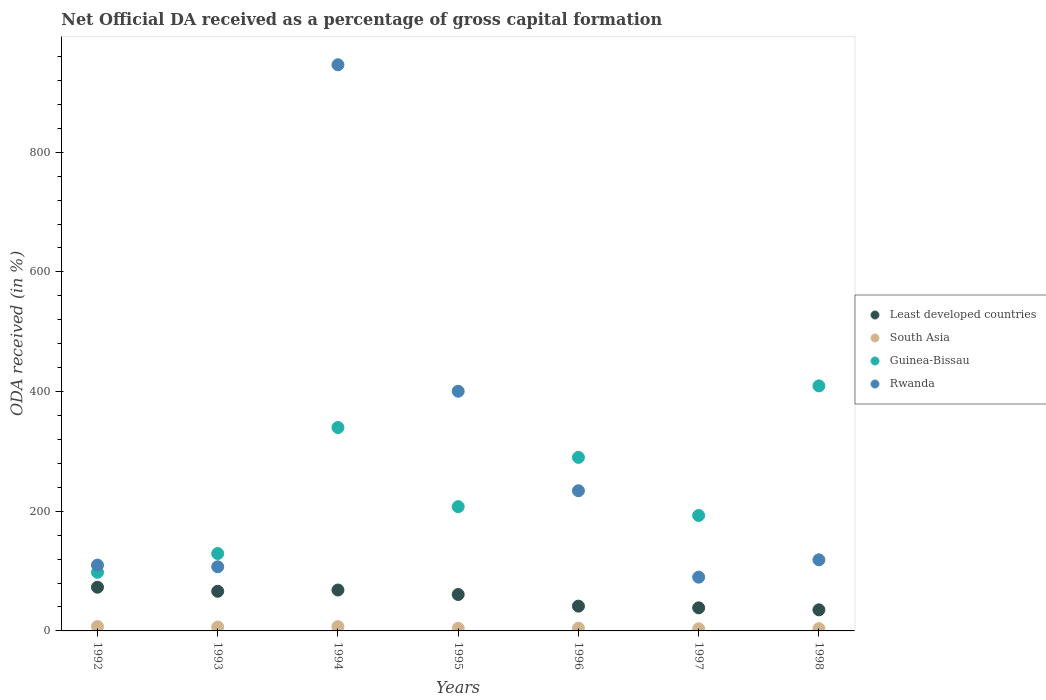Is the number of dotlines equal to the number of legend labels?
Give a very brief answer. Yes. What is the net ODA received in Rwanda in 1994?
Offer a very short reply. 946.08. Across all years, what is the maximum net ODA received in Least developed countries?
Make the answer very short. 73.05. Across all years, what is the minimum net ODA received in Least developed countries?
Provide a succinct answer. 35.24. What is the total net ODA received in Least developed countries in the graph?
Your answer should be very brief. 383.72. What is the difference between the net ODA received in Least developed countries in 1994 and that in 1996?
Provide a short and direct response. 26.97. What is the difference between the net ODA received in Guinea-Bissau in 1993 and the net ODA received in South Asia in 1996?
Offer a terse response. 124.72. What is the average net ODA received in Rwanda per year?
Keep it short and to the point. 286.67. In the year 1992, what is the difference between the net ODA received in Guinea-Bissau and net ODA received in Least developed countries?
Provide a succinct answer. 24.92. What is the ratio of the net ODA received in Guinea-Bissau in 1993 to that in 1998?
Your answer should be very brief. 0.32. What is the difference between the highest and the second highest net ODA received in Rwanda?
Provide a succinct answer. 545.56. What is the difference between the highest and the lowest net ODA received in South Asia?
Give a very brief answer. 3.85. In how many years, is the net ODA received in Guinea-Bissau greater than the average net ODA received in Guinea-Bissau taken over all years?
Your answer should be very brief. 3. Is it the case that in every year, the sum of the net ODA received in Rwanda and net ODA received in Least developed countries  is greater than the sum of net ODA received in South Asia and net ODA received in Guinea-Bissau?
Ensure brevity in your answer.  Yes. Is it the case that in every year, the sum of the net ODA received in Least developed countries and net ODA received in Guinea-Bissau  is greater than the net ODA received in Rwanda?
Your response must be concise. No. Is the net ODA received in South Asia strictly greater than the net ODA received in Rwanda over the years?
Provide a succinct answer. No. How many dotlines are there?
Your response must be concise. 4. How many years are there in the graph?
Your response must be concise. 7. Does the graph contain grids?
Give a very brief answer. No. How many legend labels are there?
Make the answer very short. 4. What is the title of the graph?
Keep it short and to the point. Net Official DA received as a percentage of gross capital formation. Does "Bahrain" appear as one of the legend labels in the graph?
Your response must be concise. No. What is the label or title of the X-axis?
Make the answer very short. Years. What is the label or title of the Y-axis?
Make the answer very short. ODA received (in %). What is the ODA received (in %) in Least developed countries in 1992?
Offer a very short reply. 73.05. What is the ODA received (in %) in South Asia in 1992?
Give a very brief answer. 7.37. What is the ODA received (in %) of Guinea-Bissau in 1992?
Your answer should be compact. 97.97. What is the ODA received (in %) in Rwanda in 1992?
Make the answer very short. 110. What is the ODA received (in %) of Least developed countries in 1993?
Provide a succinct answer. 66.23. What is the ODA received (in %) of South Asia in 1993?
Keep it short and to the point. 6.48. What is the ODA received (in %) of Guinea-Bissau in 1993?
Provide a succinct answer. 129.32. What is the ODA received (in %) of Rwanda in 1993?
Your response must be concise. 107.19. What is the ODA received (in %) of Least developed countries in 1994?
Make the answer very short. 68.37. What is the ODA received (in %) in South Asia in 1994?
Provide a succinct answer. 7.17. What is the ODA received (in %) of Guinea-Bissau in 1994?
Provide a short and direct response. 339.91. What is the ODA received (in %) in Rwanda in 1994?
Offer a very short reply. 946.08. What is the ODA received (in %) of Least developed countries in 1995?
Ensure brevity in your answer.  60.87. What is the ODA received (in %) of South Asia in 1995?
Give a very brief answer. 4.33. What is the ODA received (in %) of Guinea-Bissau in 1995?
Ensure brevity in your answer.  207.64. What is the ODA received (in %) in Rwanda in 1995?
Provide a short and direct response. 400.51. What is the ODA received (in %) in Least developed countries in 1996?
Offer a terse response. 41.4. What is the ODA received (in %) of South Asia in 1996?
Make the answer very short. 4.6. What is the ODA received (in %) in Guinea-Bissau in 1996?
Your answer should be compact. 289.99. What is the ODA received (in %) in Rwanda in 1996?
Give a very brief answer. 234.24. What is the ODA received (in %) in Least developed countries in 1997?
Offer a very short reply. 38.57. What is the ODA received (in %) of South Asia in 1997?
Your answer should be compact. 3.52. What is the ODA received (in %) of Guinea-Bissau in 1997?
Provide a short and direct response. 192.94. What is the ODA received (in %) of Rwanda in 1997?
Your response must be concise. 89.82. What is the ODA received (in %) in Least developed countries in 1998?
Keep it short and to the point. 35.24. What is the ODA received (in %) in South Asia in 1998?
Your answer should be compact. 3.8. What is the ODA received (in %) of Guinea-Bissau in 1998?
Make the answer very short. 409.5. What is the ODA received (in %) of Rwanda in 1998?
Your response must be concise. 118.84. Across all years, what is the maximum ODA received (in %) of Least developed countries?
Give a very brief answer. 73.05. Across all years, what is the maximum ODA received (in %) in South Asia?
Your answer should be compact. 7.37. Across all years, what is the maximum ODA received (in %) of Guinea-Bissau?
Provide a succinct answer. 409.5. Across all years, what is the maximum ODA received (in %) in Rwanda?
Keep it short and to the point. 946.08. Across all years, what is the minimum ODA received (in %) in Least developed countries?
Provide a short and direct response. 35.24. Across all years, what is the minimum ODA received (in %) of South Asia?
Ensure brevity in your answer.  3.52. Across all years, what is the minimum ODA received (in %) of Guinea-Bissau?
Provide a succinct answer. 97.97. Across all years, what is the minimum ODA received (in %) of Rwanda?
Your response must be concise. 89.82. What is the total ODA received (in %) of Least developed countries in the graph?
Ensure brevity in your answer.  383.72. What is the total ODA received (in %) of South Asia in the graph?
Offer a very short reply. 37.26. What is the total ODA received (in %) of Guinea-Bissau in the graph?
Make the answer very short. 1667.26. What is the total ODA received (in %) in Rwanda in the graph?
Make the answer very short. 2006.68. What is the difference between the ODA received (in %) in Least developed countries in 1992 and that in 1993?
Offer a terse response. 6.81. What is the difference between the ODA received (in %) in South Asia in 1992 and that in 1993?
Offer a very short reply. 0.89. What is the difference between the ODA received (in %) in Guinea-Bissau in 1992 and that in 1993?
Your response must be concise. -31.36. What is the difference between the ODA received (in %) of Rwanda in 1992 and that in 1993?
Your answer should be very brief. 2.81. What is the difference between the ODA received (in %) in Least developed countries in 1992 and that in 1994?
Give a very brief answer. 4.68. What is the difference between the ODA received (in %) in South Asia in 1992 and that in 1994?
Ensure brevity in your answer.  0.2. What is the difference between the ODA received (in %) in Guinea-Bissau in 1992 and that in 1994?
Your response must be concise. -241.94. What is the difference between the ODA received (in %) of Rwanda in 1992 and that in 1994?
Give a very brief answer. -836.08. What is the difference between the ODA received (in %) of Least developed countries in 1992 and that in 1995?
Ensure brevity in your answer.  12.18. What is the difference between the ODA received (in %) of South Asia in 1992 and that in 1995?
Give a very brief answer. 3.04. What is the difference between the ODA received (in %) of Guinea-Bissau in 1992 and that in 1995?
Offer a very short reply. -109.67. What is the difference between the ODA received (in %) in Rwanda in 1992 and that in 1995?
Your response must be concise. -290.52. What is the difference between the ODA received (in %) of Least developed countries in 1992 and that in 1996?
Ensure brevity in your answer.  31.65. What is the difference between the ODA received (in %) of South Asia in 1992 and that in 1996?
Your response must be concise. 2.77. What is the difference between the ODA received (in %) of Guinea-Bissau in 1992 and that in 1996?
Provide a succinct answer. -192.02. What is the difference between the ODA received (in %) in Rwanda in 1992 and that in 1996?
Provide a succinct answer. -124.24. What is the difference between the ODA received (in %) in Least developed countries in 1992 and that in 1997?
Make the answer very short. 34.48. What is the difference between the ODA received (in %) in South Asia in 1992 and that in 1997?
Offer a terse response. 3.85. What is the difference between the ODA received (in %) in Guinea-Bissau in 1992 and that in 1997?
Provide a succinct answer. -94.97. What is the difference between the ODA received (in %) of Rwanda in 1992 and that in 1997?
Offer a terse response. 20.17. What is the difference between the ODA received (in %) of Least developed countries in 1992 and that in 1998?
Give a very brief answer. 37.8. What is the difference between the ODA received (in %) in South Asia in 1992 and that in 1998?
Your answer should be compact. 3.57. What is the difference between the ODA received (in %) of Guinea-Bissau in 1992 and that in 1998?
Your answer should be compact. -311.53. What is the difference between the ODA received (in %) of Rwanda in 1992 and that in 1998?
Make the answer very short. -8.84. What is the difference between the ODA received (in %) of Least developed countries in 1993 and that in 1994?
Your answer should be very brief. -2.13. What is the difference between the ODA received (in %) in South Asia in 1993 and that in 1994?
Offer a terse response. -0.69. What is the difference between the ODA received (in %) of Guinea-Bissau in 1993 and that in 1994?
Offer a terse response. -210.58. What is the difference between the ODA received (in %) of Rwanda in 1993 and that in 1994?
Make the answer very short. -838.89. What is the difference between the ODA received (in %) of Least developed countries in 1993 and that in 1995?
Make the answer very short. 5.37. What is the difference between the ODA received (in %) in South Asia in 1993 and that in 1995?
Provide a short and direct response. 2.15. What is the difference between the ODA received (in %) in Guinea-Bissau in 1993 and that in 1995?
Keep it short and to the point. -78.31. What is the difference between the ODA received (in %) of Rwanda in 1993 and that in 1995?
Offer a terse response. -293.32. What is the difference between the ODA received (in %) of Least developed countries in 1993 and that in 1996?
Ensure brevity in your answer.  24.84. What is the difference between the ODA received (in %) of South Asia in 1993 and that in 1996?
Your answer should be compact. 1.88. What is the difference between the ODA received (in %) of Guinea-Bissau in 1993 and that in 1996?
Provide a succinct answer. -160.66. What is the difference between the ODA received (in %) in Rwanda in 1993 and that in 1996?
Offer a terse response. -127.05. What is the difference between the ODA received (in %) in Least developed countries in 1993 and that in 1997?
Provide a succinct answer. 27.67. What is the difference between the ODA received (in %) of South Asia in 1993 and that in 1997?
Your answer should be very brief. 2.96. What is the difference between the ODA received (in %) of Guinea-Bissau in 1993 and that in 1997?
Your answer should be very brief. -63.62. What is the difference between the ODA received (in %) of Rwanda in 1993 and that in 1997?
Offer a very short reply. 17.37. What is the difference between the ODA received (in %) of Least developed countries in 1993 and that in 1998?
Ensure brevity in your answer.  30.99. What is the difference between the ODA received (in %) in South Asia in 1993 and that in 1998?
Your response must be concise. 2.67. What is the difference between the ODA received (in %) in Guinea-Bissau in 1993 and that in 1998?
Offer a terse response. -280.17. What is the difference between the ODA received (in %) in Rwanda in 1993 and that in 1998?
Provide a succinct answer. -11.65. What is the difference between the ODA received (in %) in Least developed countries in 1994 and that in 1995?
Your answer should be compact. 7.5. What is the difference between the ODA received (in %) in South Asia in 1994 and that in 1995?
Give a very brief answer. 2.84. What is the difference between the ODA received (in %) of Guinea-Bissau in 1994 and that in 1995?
Give a very brief answer. 132.27. What is the difference between the ODA received (in %) of Rwanda in 1994 and that in 1995?
Your answer should be very brief. 545.56. What is the difference between the ODA received (in %) of Least developed countries in 1994 and that in 1996?
Provide a short and direct response. 26.97. What is the difference between the ODA received (in %) of South Asia in 1994 and that in 1996?
Provide a short and direct response. 2.57. What is the difference between the ODA received (in %) in Guinea-Bissau in 1994 and that in 1996?
Keep it short and to the point. 49.92. What is the difference between the ODA received (in %) in Rwanda in 1994 and that in 1996?
Your response must be concise. 711.84. What is the difference between the ODA received (in %) in Least developed countries in 1994 and that in 1997?
Your answer should be very brief. 29.8. What is the difference between the ODA received (in %) of South Asia in 1994 and that in 1997?
Ensure brevity in your answer.  3.65. What is the difference between the ODA received (in %) of Guinea-Bissau in 1994 and that in 1997?
Ensure brevity in your answer.  146.97. What is the difference between the ODA received (in %) in Rwanda in 1994 and that in 1997?
Give a very brief answer. 856.25. What is the difference between the ODA received (in %) of Least developed countries in 1994 and that in 1998?
Your answer should be very brief. 33.12. What is the difference between the ODA received (in %) in South Asia in 1994 and that in 1998?
Offer a very short reply. 3.37. What is the difference between the ODA received (in %) of Guinea-Bissau in 1994 and that in 1998?
Ensure brevity in your answer.  -69.59. What is the difference between the ODA received (in %) in Rwanda in 1994 and that in 1998?
Give a very brief answer. 827.24. What is the difference between the ODA received (in %) in Least developed countries in 1995 and that in 1996?
Offer a very short reply. 19.47. What is the difference between the ODA received (in %) of South Asia in 1995 and that in 1996?
Give a very brief answer. -0.27. What is the difference between the ODA received (in %) of Guinea-Bissau in 1995 and that in 1996?
Your response must be concise. -82.35. What is the difference between the ODA received (in %) of Rwanda in 1995 and that in 1996?
Provide a short and direct response. 166.28. What is the difference between the ODA received (in %) in Least developed countries in 1995 and that in 1997?
Ensure brevity in your answer.  22.3. What is the difference between the ODA received (in %) in South Asia in 1995 and that in 1997?
Give a very brief answer. 0.81. What is the difference between the ODA received (in %) in Guinea-Bissau in 1995 and that in 1997?
Provide a succinct answer. 14.7. What is the difference between the ODA received (in %) in Rwanda in 1995 and that in 1997?
Make the answer very short. 310.69. What is the difference between the ODA received (in %) of Least developed countries in 1995 and that in 1998?
Provide a succinct answer. 25.63. What is the difference between the ODA received (in %) in South Asia in 1995 and that in 1998?
Ensure brevity in your answer.  0.53. What is the difference between the ODA received (in %) of Guinea-Bissau in 1995 and that in 1998?
Provide a succinct answer. -201.86. What is the difference between the ODA received (in %) in Rwanda in 1995 and that in 1998?
Make the answer very short. 281.68. What is the difference between the ODA received (in %) of Least developed countries in 1996 and that in 1997?
Your response must be concise. 2.83. What is the difference between the ODA received (in %) of South Asia in 1996 and that in 1997?
Your answer should be compact. 1.08. What is the difference between the ODA received (in %) in Guinea-Bissau in 1996 and that in 1997?
Offer a terse response. 97.05. What is the difference between the ODA received (in %) of Rwanda in 1996 and that in 1997?
Offer a terse response. 144.42. What is the difference between the ODA received (in %) of Least developed countries in 1996 and that in 1998?
Give a very brief answer. 6.16. What is the difference between the ODA received (in %) in South Asia in 1996 and that in 1998?
Offer a very short reply. 0.8. What is the difference between the ODA received (in %) in Guinea-Bissau in 1996 and that in 1998?
Keep it short and to the point. -119.51. What is the difference between the ODA received (in %) of Rwanda in 1996 and that in 1998?
Make the answer very short. 115.4. What is the difference between the ODA received (in %) of Least developed countries in 1997 and that in 1998?
Your answer should be compact. 3.33. What is the difference between the ODA received (in %) in South Asia in 1997 and that in 1998?
Ensure brevity in your answer.  -0.28. What is the difference between the ODA received (in %) of Guinea-Bissau in 1997 and that in 1998?
Ensure brevity in your answer.  -216.56. What is the difference between the ODA received (in %) in Rwanda in 1997 and that in 1998?
Provide a short and direct response. -29.02. What is the difference between the ODA received (in %) in Least developed countries in 1992 and the ODA received (in %) in South Asia in 1993?
Provide a short and direct response. 66.57. What is the difference between the ODA received (in %) of Least developed countries in 1992 and the ODA received (in %) of Guinea-Bissau in 1993?
Offer a terse response. -56.28. What is the difference between the ODA received (in %) of Least developed countries in 1992 and the ODA received (in %) of Rwanda in 1993?
Your answer should be very brief. -34.14. What is the difference between the ODA received (in %) of South Asia in 1992 and the ODA received (in %) of Guinea-Bissau in 1993?
Offer a terse response. -121.96. What is the difference between the ODA received (in %) in South Asia in 1992 and the ODA received (in %) in Rwanda in 1993?
Your answer should be very brief. -99.82. What is the difference between the ODA received (in %) in Guinea-Bissau in 1992 and the ODA received (in %) in Rwanda in 1993?
Your answer should be very brief. -9.22. What is the difference between the ODA received (in %) of Least developed countries in 1992 and the ODA received (in %) of South Asia in 1994?
Your response must be concise. 65.88. What is the difference between the ODA received (in %) in Least developed countries in 1992 and the ODA received (in %) in Guinea-Bissau in 1994?
Your answer should be compact. -266.86. What is the difference between the ODA received (in %) in Least developed countries in 1992 and the ODA received (in %) in Rwanda in 1994?
Give a very brief answer. -873.03. What is the difference between the ODA received (in %) of South Asia in 1992 and the ODA received (in %) of Guinea-Bissau in 1994?
Give a very brief answer. -332.54. What is the difference between the ODA received (in %) of South Asia in 1992 and the ODA received (in %) of Rwanda in 1994?
Your answer should be very brief. -938.71. What is the difference between the ODA received (in %) of Guinea-Bissau in 1992 and the ODA received (in %) of Rwanda in 1994?
Your answer should be compact. -848.11. What is the difference between the ODA received (in %) of Least developed countries in 1992 and the ODA received (in %) of South Asia in 1995?
Provide a short and direct response. 68.72. What is the difference between the ODA received (in %) in Least developed countries in 1992 and the ODA received (in %) in Guinea-Bissau in 1995?
Your answer should be very brief. -134.59. What is the difference between the ODA received (in %) of Least developed countries in 1992 and the ODA received (in %) of Rwanda in 1995?
Your answer should be compact. -327.47. What is the difference between the ODA received (in %) in South Asia in 1992 and the ODA received (in %) in Guinea-Bissau in 1995?
Your answer should be compact. -200.27. What is the difference between the ODA received (in %) in South Asia in 1992 and the ODA received (in %) in Rwanda in 1995?
Your answer should be compact. -393.15. What is the difference between the ODA received (in %) in Guinea-Bissau in 1992 and the ODA received (in %) in Rwanda in 1995?
Make the answer very short. -302.55. What is the difference between the ODA received (in %) of Least developed countries in 1992 and the ODA received (in %) of South Asia in 1996?
Keep it short and to the point. 68.45. What is the difference between the ODA received (in %) of Least developed countries in 1992 and the ODA received (in %) of Guinea-Bissau in 1996?
Your response must be concise. -216.94. What is the difference between the ODA received (in %) in Least developed countries in 1992 and the ODA received (in %) in Rwanda in 1996?
Keep it short and to the point. -161.19. What is the difference between the ODA received (in %) in South Asia in 1992 and the ODA received (in %) in Guinea-Bissau in 1996?
Ensure brevity in your answer.  -282.62. What is the difference between the ODA received (in %) of South Asia in 1992 and the ODA received (in %) of Rwanda in 1996?
Your answer should be very brief. -226.87. What is the difference between the ODA received (in %) of Guinea-Bissau in 1992 and the ODA received (in %) of Rwanda in 1996?
Provide a short and direct response. -136.27. What is the difference between the ODA received (in %) of Least developed countries in 1992 and the ODA received (in %) of South Asia in 1997?
Ensure brevity in your answer.  69.53. What is the difference between the ODA received (in %) of Least developed countries in 1992 and the ODA received (in %) of Guinea-Bissau in 1997?
Make the answer very short. -119.89. What is the difference between the ODA received (in %) in Least developed countries in 1992 and the ODA received (in %) in Rwanda in 1997?
Offer a very short reply. -16.78. What is the difference between the ODA received (in %) of South Asia in 1992 and the ODA received (in %) of Guinea-Bissau in 1997?
Your response must be concise. -185.57. What is the difference between the ODA received (in %) in South Asia in 1992 and the ODA received (in %) in Rwanda in 1997?
Give a very brief answer. -82.45. What is the difference between the ODA received (in %) of Guinea-Bissau in 1992 and the ODA received (in %) of Rwanda in 1997?
Ensure brevity in your answer.  8.14. What is the difference between the ODA received (in %) in Least developed countries in 1992 and the ODA received (in %) in South Asia in 1998?
Give a very brief answer. 69.24. What is the difference between the ODA received (in %) in Least developed countries in 1992 and the ODA received (in %) in Guinea-Bissau in 1998?
Make the answer very short. -336.45. What is the difference between the ODA received (in %) in Least developed countries in 1992 and the ODA received (in %) in Rwanda in 1998?
Your answer should be compact. -45.79. What is the difference between the ODA received (in %) of South Asia in 1992 and the ODA received (in %) of Guinea-Bissau in 1998?
Your answer should be compact. -402.13. What is the difference between the ODA received (in %) of South Asia in 1992 and the ODA received (in %) of Rwanda in 1998?
Your response must be concise. -111.47. What is the difference between the ODA received (in %) in Guinea-Bissau in 1992 and the ODA received (in %) in Rwanda in 1998?
Provide a short and direct response. -20.87. What is the difference between the ODA received (in %) of Least developed countries in 1993 and the ODA received (in %) of South Asia in 1994?
Offer a very short reply. 59.07. What is the difference between the ODA received (in %) of Least developed countries in 1993 and the ODA received (in %) of Guinea-Bissau in 1994?
Provide a short and direct response. -273.67. What is the difference between the ODA received (in %) of Least developed countries in 1993 and the ODA received (in %) of Rwanda in 1994?
Your answer should be very brief. -879.84. What is the difference between the ODA received (in %) in South Asia in 1993 and the ODA received (in %) in Guinea-Bissau in 1994?
Offer a very short reply. -333.43. What is the difference between the ODA received (in %) in South Asia in 1993 and the ODA received (in %) in Rwanda in 1994?
Your answer should be very brief. -939.6. What is the difference between the ODA received (in %) of Guinea-Bissau in 1993 and the ODA received (in %) of Rwanda in 1994?
Your response must be concise. -816.75. What is the difference between the ODA received (in %) of Least developed countries in 1993 and the ODA received (in %) of South Asia in 1995?
Your response must be concise. 61.91. What is the difference between the ODA received (in %) of Least developed countries in 1993 and the ODA received (in %) of Guinea-Bissau in 1995?
Give a very brief answer. -141.4. What is the difference between the ODA received (in %) in Least developed countries in 1993 and the ODA received (in %) in Rwanda in 1995?
Provide a succinct answer. -334.28. What is the difference between the ODA received (in %) in South Asia in 1993 and the ODA received (in %) in Guinea-Bissau in 1995?
Your response must be concise. -201.16. What is the difference between the ODA received (in %) of South Asia in 1993 and the ODA received (in %) of Rwanda in 1995?
Provide a succinct answer. -394.04. What is the difference between the ODA received (in %) in Guinea-Bissau in 1993 and the ODA received (in %) in Rwanda in 1995?
Give a very brief answer. -271.19. What is the difference between the ODA received (in %) of Least developed countries in 1993 and the ODA received (in %) of South Asia in 1996?
Offer a very short reply. 61.64. What is the difference between the ODA received (in %) in Least developed countries in 1993 and the ODA received (in %) in Guinea-Bissau in 1996?
Provide a short and direct response. -223.75. What is the difference between the ODA received (in %) in Least developed countries in 1993 and the ODA received (in %) in Rwanda in 1996?
Offer a terse response. -168. What is the difference between the ODA received (in %) of South Asia in 1993 and the ODA received (in %) of Guinea-Bissau in 1996?
Provide a short and direct response. -283.51. What is the difference between the ODA received (in %) of South Asia in 1993 and the ODA received (in %) of Rwanda in 1996?
Offer a terse response. -227.76. What is the difference between the ODA received (in %) in Guinea-Bissau in 1993 and the ODA received (in %) in Rwanda in 1996?
Offer a very short reply. -104.92. What is the difference between the ODA received (in %) of Least developed countries in 1993 and the ODA received (in %) of South Asia in 1997?
Provide a short and direct response. 62.72. What is the difference between the ODA received (in %) in Least developed countries in 1993 and the ODA received (in %) in Guinea-Bissau in 1997?
Provide a succinct answer. -126.7. What is the difference between the ODA received (in %) of Least developed countries in 1993 and the ODA received (in %) of Rwanda in 1997?
Keep it short and to the point. -23.59. What is the difference between the ODA received (in %) of South Asia in 1993 and the ODA received (in %) of Guinea-Bissau in 1997?
Make the answer very short. -186.46. What is the difference between the ODA received (in %) of South Asia in 1993 and the ODA received (in %) of Rwanda in 1997?
Your response must be concise. -83.35. What is the difference between the ODA received (in %) of Guinea-Bissau in 1993 and the ODA received (in %) of Rwanda in 1997?
Make the answer very short. 39.5. What is the difference between the ODA received (in %) in Least developed countries in 1993 and the ODA received (in %) in South Asia in 1998?
Your response must be concise. 62.43. What is the difference between the ODA received (in %) in Least developed countries in 1993 and the ODA received (in %) in Guinea-Bissau in 1998?
Offer a very short reply. -343.26. What is the difference between the ODA received (in %) of Least developed countries in 1993 and the ODA received (in %) of Rwanda in 1998?
Offer a terse response. -52.6. What is the difference between the ODA received (in %) of South Asia in 1993 and the ODA received (in %) of Guinea-Bissau in 1998?
Ensure brevity in your answer.  -403.02. What is the difference between the ODA received (in %) in South Asia in 1993 and the ODA received (in %) in Rwanda in 1998?
Keep it short and to the point. -112.36. What is the difference between the ODA received (in %) of Guinea-Bissau in 1993 and the ODA received (in %) of Rwanda in 1998?
Your answer should be very brief. 10.49. What is the difference between the ODA received (in %) in Least developed countries in 1994 and the ODA received (in %) in South Asia in 1995?
Offer a terse response. 64.04. What is the difference between the ODA received (in %) of Least developed countries in 1994 and the ODA received (in %) of Guinea-Bissau in 1995?
Your answer should be very brief. -139.27. What is the difference between the ODA received (in %) of Least developed countries in 1994 and the ODA received (in %) of Rwanda in 1995?
Make the answer very short. -332.15. What is the difference between the ODA received (in %) of South Asia in 1994 and the ODA received (in %) of Guinea-Bissau in 1995?
Provide a short and direct response. -200.47. What is the difference between the ODA received (in %) in South Asia in 1994 and the ODA received (in %) in Rwanda in 1995?
Your answer should be compact. -393.34. What is the difference between the ODA received (in %) in Guinea-Bissau in 1994 and the ODA received (in %) in Rwanda in 1995?
Give a very brief answer. -60.61. What is the difference between the ODA received (in %) of Least developed countries in 1994 and the ODA received (in %) of South Asia in 1996?
Offer a very short reply. 63.77. What is the difference between the ODA received (in %) in Least developed countries in 1994 and the ODA received (in %) in Guinea-Bissau in 1996?
Ensure brevity in your answer.  -221.62. What is the difference between the ODA received (in %) of Least developed countries in 1994 and the ODA received (in %) of Rwanda in 1996?
Offer a terse response. -165.87. What is the difference between the ODA received (in %) of South Asia in 1994 and the ODA received (in %) of Guinea-Bissau in 1996?
Your response must be concise. -282.82. What is the difference between the ODA received (in %) in South Asia in 1994 and the ODA received (in %) in Rwanda in 1996?
Offer a very short reply. -227.07. What is the difference between the ODA received (in %) in Guinea-Bissau in 1994 and the ODA received (in %) in Rwanda in 1996?
Keep it short and to the point. 105.67. What is the difference between the ODA received (in %) in Least developed countries in 1994 and the ODA received (in %) in South Asia in 1997?
Provide a short and direct response. 64.85. What is the difference between the ODA received (in %) in Least developed countries in 1994 and the ODA received (in %) in Guinea-Bissau in 1997?
Your answer should be compact. -124.57. What is the difference between the ODA received (in %) of Least developed countries in 1994 and the ODA received (in %) of Rwanda in 1997?
Offer a terse response. -21.46. What is the difference between the ODA received (in %) in South Asia in 1994 and the ODA received (in %) in Guinea-Bissau in 1997?
Your answer should be compact. -185.77. What is the difference between the ODA received (in %) of South Asia in 1994 and the ODA received (in %) of Rwanda in 1997?
Your answer should be compact. -82.65. What is the difference between the ODA received (in %) in Guinea-Bissau in 1994 and the ODA received (in %) in Rwanda in 1997?
Your response must be concise. 250.09. What is the difference between the ODA received (in %) of Least developed countries in 1994 and the ODA received (in %) of South Asia in 1998?
Provide a short and direct response. 64.56. What is the difference between the ODA received (in %) of Least developed countries in 1994 and the ODA received (in %) of Guinea-Bissau in 1998?
Provide a succinct answer. -341.13. What is the difference between the ODA received (in %) of Least developed countries in 1994 and the ODA received (in %) of Rwanda in 1998?
Offer a terse response. -50.47. What is the difference between the ODA received (in %) in South Asia in 1994 and the ODA received (in %) in Guinea-Bissau in 1998?
Provide a succinct answer. -402.33. What is the difference between the ODA received (in %) in South Asia in 1994 and the ODA received (in %) in Rwanda in 1998?
Your answer should be very brief. -111.67. What is the difference between the ODA received (in %) of Guinea-Bissau in 1994 and the ODA received (in %) of Rwanda in 1998?
Provide a succinct answer. 221.07. What is the difference between the ODA received (in %) in Least developed countries in 1995 and the ODA received (in %) in South Asia in 1996?
Provide a short and direct response. 56.27. What is the difference between the ODA received (in %) in Least developed countries in 1995 and the ODA received (in %) in Guinea-Bissau in 1996?
Give a very brief answer. -229.12. What is the difference between the ODA received (in %) of Least developed countries in 1995 and the ODA received (in %) of Rwanda in 1996?
Make the answer very short. -173.37. What is the difference between the ODA received (in %) in South Asia in 1995 and the ODA received (in %) in Guinea-Bissau in 1996?
Give a very brief answer. -285.66. What is the difference between the ODA received (in %) of South Asia in 1995 and the ODA received (in %) of Rwanda in 1996?
Offer a terse response. -229.91. What is the difference between the ODA received (in %) in Guinea-Bissau in 1995 and the ODA received (in %) in Rwanda in 1996?
Give a very brief answer. -26.6. What is the difference between the ODA received (in %) of Least developed countries in 1995 and the ODA received (in %) of South Asia in 1997?
Offer a terse response. 57.35. What is the difference between the ODA received (in %) of Least developed countries in 1995 and the ODA received (in %) of Guinea-Bissau in 1997?
Your answer should be compact. -132.07. What is the difference between the ODA received (in %) in Least developed countries in 1995 and the ODA received (in %) in Rwanda in 1997?
Give a very brief answer. -28.95. What is the difference between the ODA received (in %) of South Asia in 1995 and the ODA received (in %) of Guinea-Bissau in 1997?
Make the answer very short. -188.61. What is the difference between the ODA received (in %) in South Asia in 1995 and the ODA received (in %) in Rwanda in 1997?
Give a very brief answer. -85.49. What is the difference between the ODA received (in %) in Guinea-Bissau in 1995 and the ODA received (in %) in Rwanda in 1997?
Your answer should be compact. 117.82. What is the difference between the ODA received (in %) of Least developed countries in 1995 and the ODA received (in %) of South Asia in 1998?
Your answer should be compact. 57.07. What is the difference between the ODA received (in %) in Least developed countries in 1995 and the ODA received (in %) in Guinea-Bissau in 1998?
Your answer should be very brief. -348.63. What is the difference between the ODA received (in %) of Least developed countries in 1995 and the ODA received (in %) of Rwanda in 1998?
Your answer should be compact. -57.97. What is the difference between the ODA received (in %) in South Asia in 1995 and the ODA received (in %) in Guinea-Bissau in 1998?
Offer a very short reply. -405.17. What is the difference between the ODA received (in %) of South Asia in 1995 and the ODA received (in %) of Rwanda in 1998?
Provide a short and direct response. -114.51. What is the difference between the ODA received (in %) in Guinea-Bissau in 1995 and the ODA received (in %) in Rwanda in 1998?
Your answer should be compact. 88.8. What is the difference between the ODA received (in %) in Least developed countries in 1996 and the ODA received (in %) in South Asia in 1997?
Your response must be concise. 37.88. What is the difference between the ODA received (in %) of Least developed countries in 1996 and the ODA received (in %) of Guinea-Bissau in 1997?
Provide a short and direct response. -151.54. What is the difference between the ODA received (in %) in Least developed countries in 1996 and the ODA received (in %) in Rwanda in 1997?
Give a very brief answer. -48.42. What is the difference between the ODA received (in %) of South Asia in 1996 and the ODA received (in %) of Guinea-Bissau in 1997?
Provide a short and direct response. -188.34. What is the difference between the ODA received (in %) in South Asia in 1996 and the ODA received (in %) in Rwanda in 1997?
Provide a short and direct response. -85.22. What is the difference between the ODA received (in %) in Guinea-Bissau in 1996 and the ODA received (in %) in Rwanda in 1997?
Keep it short and to the point. 200.17. What is the difference between the ODA received (in %) in Least developed countries in 1996 and the ODA received (in %) in South Asia in 1998?
Offer a very short reply. 37.6. What is the difference between the ODA received (in %) of Least developed countries in 1996 and the ODA received (in %) of Guinea-Bissau in 1998?
Make the answer very short. -368.1. What is the difference between the ODA received (in %) in Least developed countries in 1996 and the ODA received (in %) in Rwanda in 1998?
Offer a terse response. -77.44. What is the difference between the ODA received (in %) of South Asia in 1996 and the ODA received (in %) of Guinea-Bissau in 1998?
Offer a very short reply. -404.9. What is the difference between the ODA received (in %) in South Asia in 1996 and the ODA received (in %) in Rwanda in 1998?
Provide a succinct answer. -114.24. What is the difference between the ODA received (in %) of Guinea-Bissau in 1996 and the ODA received (in %) of Rwanda in 1998?
Make the answer very short. 171.15. What is the difference between the ODA received (in %) of Least developed countries in 1997 and the ODA received (in %) of South Asia in 1998?
Your answer should be compact. 34.77. What is the difference between the ODA received (in %) of Least developed countries in 1997 and the ODA received (in %) of Guinea-Bissau in 1998?
Offer a terse response. -370.93. What is the difference between the ODA received (in %) of Least developed countries in 1997 and the ODA received (in %) of Rwanda in 1998?
Keep it short and to the point. -80.27. What is the difference between the ODA received (in %) of South Asia in 1997 and the ODA received (in %) of Guinea-Bissau in 1998?
Keep it short and to the point. -405.98. What is the difference between the ODA received (in %) of South Asia in 1997 and the ODA received (in %) of Rwanda in 1998?
Offer a very short reply. -115.32. What is the difference between the ODA received (in %) in Guinea-Bissau in 1997 and the ODA received (in %) in Rwanda in 1998?
Offer a terse response. 74.1. What is the average ODA received (in %) in Least developed countries per year?
Your response must be concise. 54.82. What is the average ODA received (in %) in South Asia per year?
Offer a very short reply. 5.32. What is the average ODA received (in %) of Guinea-Bissau per year?
Give a very brief answer. 238.18. What is the average ODA received (in %) in Rwanda per year?
Provide a succinct answer. 286.67. In the year 1992, what is the difference between the ODA received (in %) in Least developed countries and ODA received (in %) in South Asia?
Your answer should be very brief. 65.68. In the year 1992, what is the difference between the ODA received (in %) in Least developed countries and ODA received (in %) in Guinea-Bissau?
Offer a very short reply. -24.92. In the year 1992, what is the difference between the ODA received (in %) in Least developed countries and ODA received (in %) in Rwanda?
Provide a succinct answer. -36.95. In the year 1992, what is the difference between the ODA received (in %) in South Asia and ODA received (in %) in Guinea-Bissau?
Your response must be concise. -90.6. In the year 1992, what is the difference between the ODA received (in %) of South Asia and ODA received (in %) of Rwanda?
Provide a short and direct response. -102.63. In the year 1992, what is the difference between the ODA received (in %) of Guinea-Bissau and ODA received (in %) of Rwanda?
Give a very brief answer. -12.03. In the year 1993, what is the difference between the ODA received (in %) of Least developed countries and ODA received (in %) of South Asia?
Your answer should be very brief. 59.76. In the year 1993, what is the difference between the ODA received (in %) of Least developed countries and ODA received (in %) of Guinea-Bissau?
Your response must be concise. -63.09. In the year 1993, what is the difference between the ODA received (in %) of Least developed countries and ODA received (in %) of Rwanda?
Give a very brief answer. -40.95. In the year 1993, what is the difference between the ODA received (in %) of South Asia and ODA received (in %) of Guinea-Bissau?
Make the answer very short. -122.85. In the year 1993, what is the difference between the ODA received (in %) in South Asia and ODA received (in %) in Rwanda?
Offer a terse response. -100.71. In the year 1993, what is the difference between the ODA received (in %) in Guinea-Bissau and ODA received (in %) in Rwanda?
Make the answer very short. 22.13. In the year 1994, what is the difference between the ODA received (in %) of Least developed countries and ODA received (in %) of South Asia?
Make the answer very short. 61.2. In the year 1994, what is the difference between the ODA received (in %) in Least developed countries and ODA received (in %) in Guinea-Bissau?
Give a very brief answer. -271.54. In the year 1994, what is the difference between the ODA received (in %) of Least developed countries and ODA received (in %) of Rwanda?
Your answer should be compact. -877.71. In the year 1994, what is the difference between the ODA received (in %) in South Asia and ODA received (in %) in Guinea-Bissau?
Your response must be concise. -332.74. In the year 1994, what is the difference between the ODA received (in %) in South Asia and ODA received (in %) in Rwanda?
Give a very brief answer. -938.91. In the year 1994, what is the difference between the ODA received (in %) of Guinea-Bissau and ODA received (in %) of Rwanda?
Your response must be concise. -606.17. In the year 1995, what is the difference between the ODA received (in %) of Least developed countries and ODA received (in %) of South Asia?
Provide a short and direct response. 56.54. In the year 1995, what is the difference between the ODA received (in %) of Least developed countries and ODA received (in %) of Guinea-Bissau?
Offer a terse response. -146.77. In the year 1995, what is the difference between the ODA received (in %) in Least developed countries and ODA received (in %) in Rwanda?
Provide a succinct answer. -339.65. In the year 1995, what is the difference between the ODA received (in %) in South Asia and ODA received (in %) in Guinea-Bissau?
Keep it short and to the point. -203.31. In the year 1995, what is the difference between the ODA received (in %) of South Asia and ODA received (in %) of Rwanda?
Provide a short and direct response. -396.19. In the year 1995, what is the difference between the ODA received (in %) of Guinea-Bissau and ODA received (in %) of Rwanda?
Your answer should be very brief. -192.88. In the year 1996, what is the difference between the ODA received (in %) in Least developed countries and ODA received (in %) in South Asia?
Provide a succinct answer. 36.8. In the year 1996, what is the difference between the ODA received (in %) of Least developed countries and ODA received (in %) of Guinea-Bissau?
Offer a very short reply. -248.59. In the year 1996, what is the difference between the ODA received (in %) in Least developed countries and ODA received (in %) in Rwanda?
Provide a succinct answer. -192.84. In the year 1996, what is the difference between the ODA received (in %) of South Asia and ODA received (in %) of Guinea-Bissau?
Keep it short and to the point. -285.39. In the year 1996, what is the difference between the ODA received (in %) in South Asia and ODA received (in %) in Rwanda?
Keep it short and to the point. -229.64. In the year 1996, what is the difference between the ODA received (in %) of Guinea-Bissau and ODA received (in %) of Rwanda?
Make the answer very short. 55.75. In the year 1997, what is the difference between the ODA received (in %) of Least developed countries and ODA received (in %) of South Asia?
Make the answer very short. 35.05. In the year 1997, what is the difference between the ODA received (in %) in Least developed countries and ODA received (in %) in Guinea-Bissau?
Your response must be concise. -154.37. In the year 1997, what is the difference between the ODA received (in %) of Least developed countries and ODA received (in %) of Rwanda?
Provide a succinct answer. -51.25. In the year 1997, what is the difference between the ODA received (in %) in South Asia and ODA received (in %) in Guinea-Bissau?
Ensure brevity in your answer.  -189.42. In the year 1997, what is the difference between the ODA received (in %) in South Asia and ODA received (in %) in Rwanda?
Keep it short and to the point. -86.3. In the year 1997, what is the difference between the ODA received (in %) in Guinea-Bissau and ODA received (in %) in Rwanda?
Provide a succinct answer. 103.12. In the year 1998, what is the difference between the ODA received (in %) of Least developed countries and ODA received (in %) of South Asia?
Ensure brevity in your answer.  31.44. In the year 1998, what is the difference between the ODA received (in %) of Least developed countries and ODA received (in %) of Guinea-Bissau?
Your answer should be very brief. -374.25. In the year 1998, what is the difference between the ODA received (in %) in Least developed countries and ODA received (in %) in Rwanda?
Your response must be concise. -83.6. In the year 1998, what is the difference between the ODA received (in %) in South Asia and ODA received (in %) in Guinea-Bissau?
Give a very brief answer. -405.69. In the year 1998, what is the difference between the ODA received (in %) of South Asia and ODA received (in %) of Rwanda?
Provide a short and direct response. -115.04. In the year 1998, what is the difference between the ODA received (in %) of Guinea-Bissau and ODA received (in %) of Rwanda?
Keep it short and to the point. 290.66. What is the ratio of the ODA received (in %) in Least developed countries in 1992 to that in 1993?
Offer a terse response. 1.1. What is the ratio of the ODA received (in %) of South Asia in 1992 to that in 1993?
Your answer should be very brief. 1.14. What is the ratio of the ODA received (in %) of Guinea-Bissau in 1992 to that in 1993?
Make the answer very short. 0.76. What is the ratio of the ODA received (in %) in Rwanda in 1992 to that in 1993?
Provide a succinct answer. 1.03. What is the ratio of the ODA received (in %) in Least developed countries in 1992 to that in 1994?
Your answer should be very brief. 1.07. What is the ratio of the ODA received (in %) in South Asia in 1992 to that in 1994?
Your answer should be very brief. 1.03. What is the ratio of the ODA received (in %) of Guinea-Bissau in 1992 to that in 1994?
Your answer should be very brief. 0.29. What is the ratio of the ODA received (in %) of Rwanda in 1992 to that in 1994?
Provide a succinct answer. 0.12. What is the ratio of the ODA received (in %) in Least developed countries in 1992 to that in 1995?
Make the answer very short. 1.2. What is the ratio of the ODA received (in %) of South Asia in 1992 to that in 1995?
Your answer should be very brief. 1.7. What is the ratio of the ODA received (in %) in Guinea-Bissau in 1992 to that in 1995?
Your answer should be compact. 0.47. What is the ratio of the ODA received (in %) in Rwanda in 1992 to that in 1995?
Make the answer very short. 0.27. What is the ratio of the ODA received (in %) in Least developed countries in 1992 to that in 1996?
Your response must be concise. 1.76. What is the ratio of the ODA received (in %) in South Asia in 1992 to that in 1996?
Offer a terse response. 1.6. What is the ratio of the ODA received (in %) in Guinea-Bissau in 1992 to that in 1996?
Keep it short and to the point. 0.34. What is the ratio of the ODA received (in %) of Rwanda in 1992 to that in 1996?
Your response must be concise. 0.47. What is the ratio of the ODA received (in %) in Least developed countries in 1992 to that in 1997?
Keep it short and to the point. 1.89. What is the ratio of the ODA received (in %) of South Asia in 1992 to that in 1997?
Make the answer very short. 2.1. What is the ratio of the ODA received (in %) of Guinea-Bissau in 1992 to that in 1997?
Make the answer very short. 0.51. What is the ratio of the ODA received (in %) in Rwanda in 1992 to that in 1997?
Your response must be concise. 1.22. What is the ratio of the ODA received (in %) in Least developed countries in 1992 to that in 1998?
Keep it short and to the point. 2.07. What is the ratio of the ODA received (in %) of South Asia in 1992 to that in 1998?
Your answer should be compact. 1.94. What is the ratio of the ODA received (in %) in Guinea-Bissau in 1992 to that in 1998?
Your answer should be compact. 0.24. What is the ratio of the ODA received (in %) in Rwanda in 1992 to that in 1998?
Your answer should be compact. 0.93. What is the ratio of the ODA received (in %) in Least developed countries in 1993 to that in 1994?
Offer a terse response. 0.97. What is the ratio of the ODA received (in %) of South Asia in 1993 to that in 1994?
Your answer should be compact. 0.9. What is the ratio of the ODA received (in %) of Guinea-Bissau in 1993 to that in 1994?
Make the answer very short. 0.38. What is the ratio of the ODA received (in %) of Rwanda in 1993 to that in 1994?
Keep it short and to the point. 0.11. What is the ratio of the ODA received (in %) of Least developed countries in 1993 to that in 1995?
Keep it short and to the point. 1.09. What is the ratio of the ODA received (in %) in South Asia in 1993 to that in 1995?
Offer a very short reply. 1.5. What is the ratio of the ODA received (in %) in Guinea-Bissau in 1993 to that in 1995?
Offer a very short reply. 0.62. What is the ratio of the ODA received (in %) in Rwanda in 1993 to that in 1995?
Your answer should be compact. 0.27. What is the ratio of the ODA received (in %) of Least developed countries in 1993 to that in 1996?
Your answer should be compact. 1.6. What is the ratio of the ODA received (in %) in South Asia in 1993 to that in 1996?
Provide a short and direct response. 1.41. What is the ratio of the ODA received (in %) of Guinea-Bissau in 1993 to that in 1996?
Offer a terse response. 0.45. What is the ratio of the ODA received (in %) of Rwanda in 1993 to that in 1996?
Keep it short and to the point. 0.46. What is the ratio of the ODA received (in %) in Least developed countries in 1993 to that in 1997?
Your response must be concise. 1.72. What is the ratio of the ODA received (in %) of South Asia in 1993 to that in 1997?
Provide a short and direct response. 1.84. What is the ratio of the ODA received (in %) in Guinea-Bissau in 1993 to that in 1997?
Give a very brief answer. 0.67. What is the ratio of the ODA received (in %) in Rwanda in 1993 to that in 1997?
Your answer should be compact. 1.19. What is the ratio of the ODA received (in %) of Least developed countries in 1993 to that in 1998?
Offer a very short reply. 1.88. What is the ratio of the ODA received (in %) of South Asia in 1993 to that in 1998?
Ensure brevity in your answer.  1.7. What is the ratio of the ODA received (in %) of Guinea-Bissau in 1993 to that in 1998?
Your response must be concise. 0.32. What is the ratio of the ODA received (in %) of Rwanda in 1993 to that in 1998?
Ensure brevity in your answer.  0.9. What is the ratio of the ODA received (in %) in Least developed countries in 1994 to that in 1995?
Your response must be concise. 1.12. What is the ratio of the ODA received (in %) in South Asia in 1994 to that in 1995?
Offer a terse response. 1.66. What is the ratio of the ODA received (in %) in Guinea-Bissau in 1994 to that in 1995?
Give a very brief answer. 1.64. What is the ratio of the ODA received (in %) of Rwanda in 1994 to that in 1995?
Provide a short and direct response. 2.36. What is the ratio of the ODA received (in %) in Least developed countries in 1994 to that in 1996?
Offer a terse response. 1.65. What is the ratio of the ODA received (in %) of South Asia in 1994 to that in 1996?
Ensure brevity in your answer.  1.56. What is the ratio of the ODA received (in %) in Guinea-Bissau in 1994 to that in 1996?
Make the answer very short. 1.17. What is the ratio of the ODA received (in %) of Rwanda in 1994 to that in 1996?
Make the answer very short. 4.04. What is the ratio of the ODA received (in %) in Least developed countries in 1994 to that in 1997?
Provide a short and direct response. 1.77. What is the ratio of the ODA received (in %) of South Asia in 1994 to that in 1997?
Your answer should be very brief. 2.04. What is the ratio of the ODA received (in %) in Guinea-Bissau in 1994 to that in 1997?
Make the answer very short. 1.76. What is the ratio of the ODA received (in %) in Rwanda in 1994 to that in 1997?
Keep it short and to the point. 10.53. What is the ratio of the ODA received (in %) in Least developed countries in 1994 to that in 1998?
Your answer should be compact. 1.94. What is the ratio of the ODA received (in %) of South Asia in 1994 to that in 1998?
Offer a terse response. 1.89. What is the ratio of the ODA received (in %) in Guinea-Bissau in 1994 to that in 1998?
Your answer should be compact. 0.83. What is the ratio of the ODA received (in %) of Rwanda in 1994 to that in 1998?
Ensure brevity in your answer.  7.96. What is the ratio of the ODA received (in %) of Least developed countries in 1995 to that in 1996?
Provide a short and direct response. 1.47. What is the ratio of the ODA received (in %) of South Asia in 1995 to that in 1996?
Your answer should be very brief. 0.94. What is the ratio of the ODA received (in %) of Guinea-Bissau in 1995 to that in 1996?
Ensure brevity in your answer.  0.72. What is the ratio of the ODA received (in %) in Rwanda in 1995 to that in 1996?
Ensure brevity in your answer.  1.71. What is the ratio of the ODA received (in %) of Least developed countries in 1995 to that in 1997?
Give a very brief answer. 1.58. What is the ratio of the ODA received (in %) in South Asia in 1995 to that in 1997?
Make the answer very short. 1.23. What is the ratio of the ODA received (in %) of Guinea-Bissau in 1995 to that in 1997?
Offer a very short reply. 1.08. What is the ratio of the ODA received (in %) in Rwanda in 1995 to that in 1997?
Provide a succinct answer. 4.46. What is the ratio of the ODA received (in %) of Least developed countries in 1995 to that in 1998?
Your answer should be very brief. 1.73. What is the ratio of the ODA received (in %) in South Asia in 1995 to that in 1998?
Make the answer very short. 1.14. What is the ratio of the ODA received (in %) in Guinea-Bissau in 1995 to that in 1998?
Provide a succinct answer. 0.51. What is the ratio of the ODA received (in %) in Rwanda in 1995 to that in 1998?
Your answer should be compact. 3.37. What is the ratio of the ODA received (in %) in Least developed countries in 1996 to that in 1997?
Make the answer very short. 1.07. What is the ratio of the ODA received (in %) in South Asia in 1996 to that in 1997?
Keep it short and to the point. 1.31. What is the ratio of the ODA received (in %) of Guinea-Bissau in 1996 to that in 1997?
Your answer should be very brief. 1.5. What is the ratio of the ODA received (in %) of Rwanda in 1996 to that in 1997?
Your answer should be very brief. 2.61. What is the ratio of the ODA received (in %) in Least developed countries in 1996 to that in 1998?
Your answer should be very brief. 1.17. What is the ratio of the ODA received (in %) in South Asia in 1996 to that in 1998?
Offer a very short reply. 1.21. What is the ratio of the ODA received (in %) in Guinea-Bissau in 1996 to that in 1998?
Offer a very short reply. 0.71. What is the ratio of the ODA received (in %) of Rwanda in 1996 to that in 1998?
Your response must be concise. 1.97. What is the ratio of the ODA received (in %) of Least developed countries in 1997 to that in 1998?
Offer a terse response. 1.09. What is the ratio of the ODA received (in %) in South Asia in 1997 to that in 1998?
Provide a succinct answer. 0.93. What is the ratio of the ODA received (in %) of Guinea-Bissau in 1997 to that in 1998?
Ensure brevity in your answer.  0.47. What is the ratio of the ODA received (in %) of Rwanda in 1997 to that in 1998?
Your answer should be very brief. 0.76. What is the difference between the highest and the second highest ODA received (in %) in Least developed countries?
Offer a terse response. 4.68. What is the difference between the highest and the second highest ODA received (in %) of South Asia?
Provide a short and direct response. 0.2. What is the difference between the highest and the second highest ODA received (in %) of Guinea-Bissau?
Give a very brief answer. 69.59. What is the difference between the highest and the second highest ODA received (in %) in Rwanda?
Your answer should be very brief. 545.56. What is the difference between the highest and the lowest ODA received (in %) of Least developed countries?
Provide a succinct answer. 37.8. What is the difference between the highest and the lowest ODA received (in %) in South Asia?
Your response must be concise. 3.85. What is the difference between the highest and the lowest ODA received (in %) in Guinea-Bissau?
Ensure brevity in your answer.  311.53. What is the difference between the highest and the lowest ODA received (in %) of Rwanda?
Give a very brief answer. 856.25. 